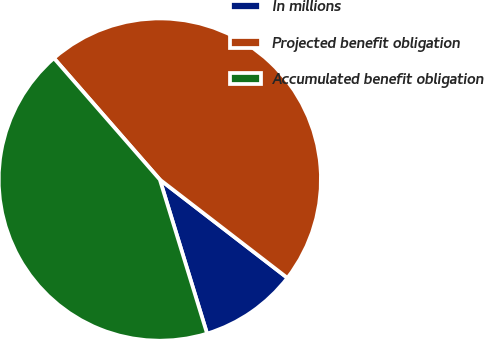<chart> <loc_0><loc_0><loc_500><loc_500><pie_chart><fcel>In millions<fcel>Projected benefit obligation<fcel>Accumulated benefit obligation<nl><fcel>9.81%<fcel>46.87%<fcel>43.32%<nl></chart> 